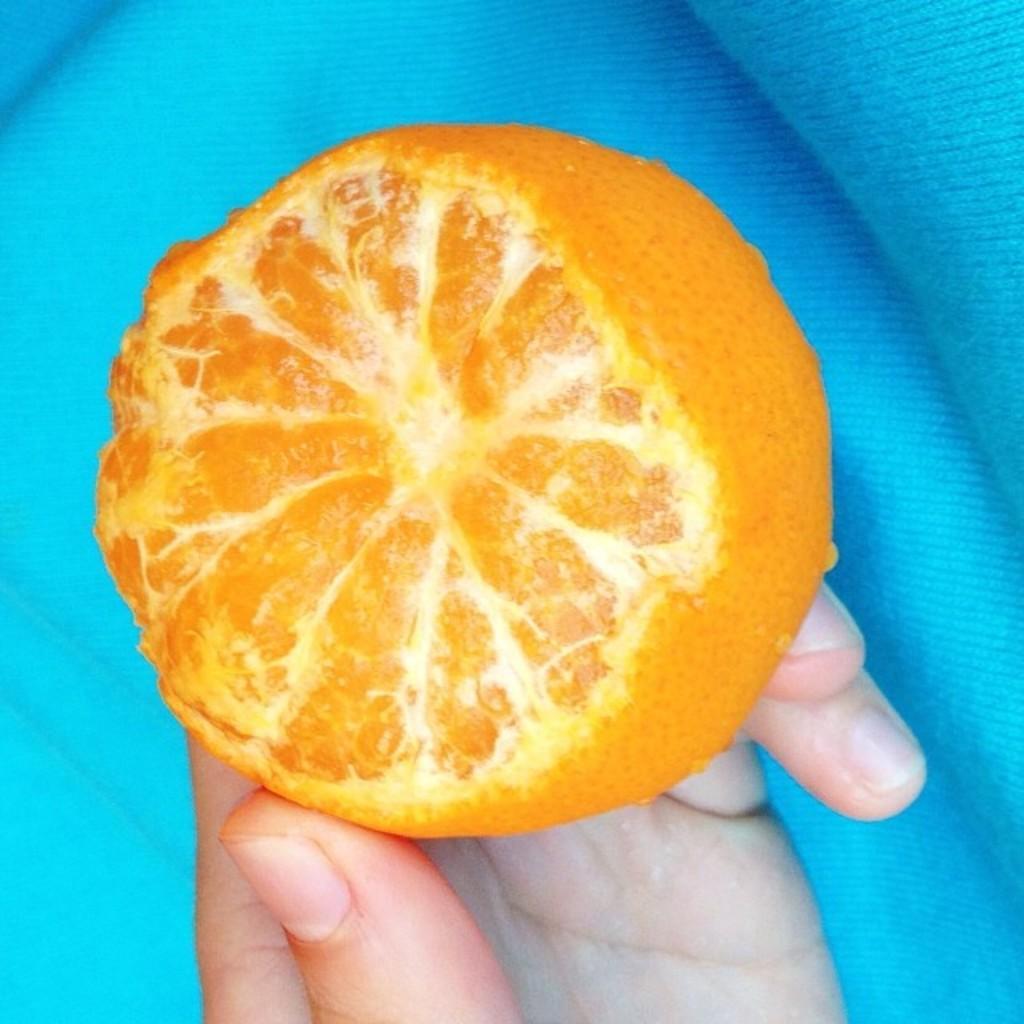Can you describe this image briefly? In this image, we can see a person's hand holding a fruit. We can also see a blue colored cloth. 